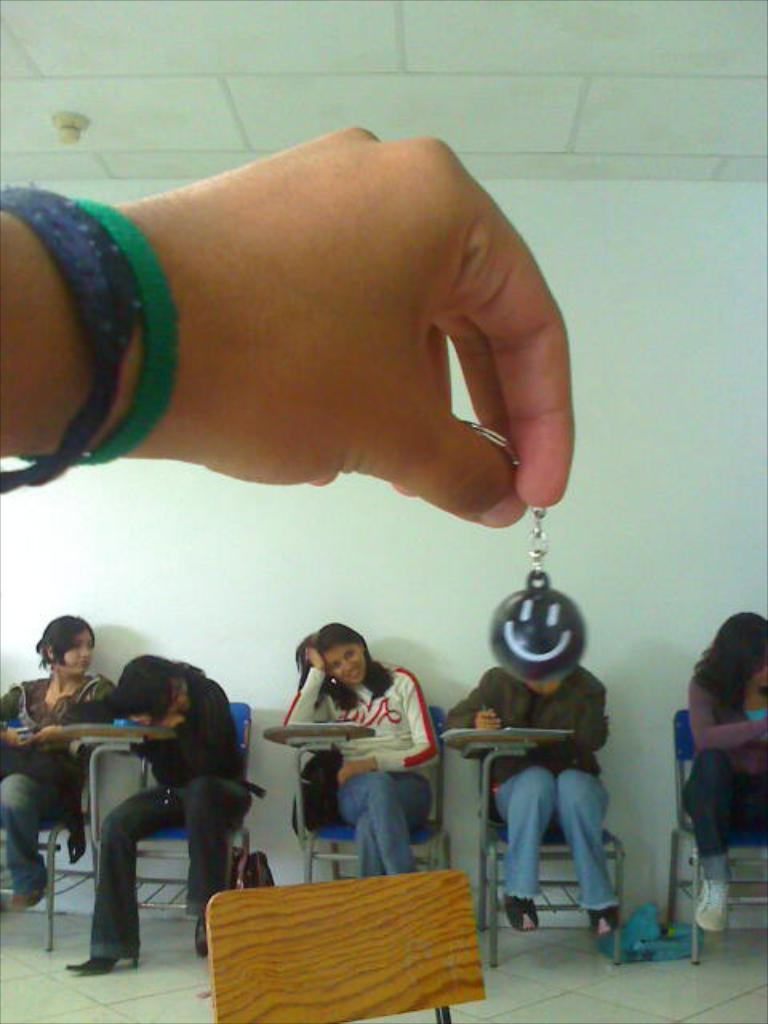What are the people in the image doing? The people in the image are sitting on chairs. Can you describe any objects that the people are holding? Yes, there is a person holding a keychain in the image. What type of market can be seen in the image? There is no market present in the image. What is the condition of the fire in the image? There is no fire present in the image. 